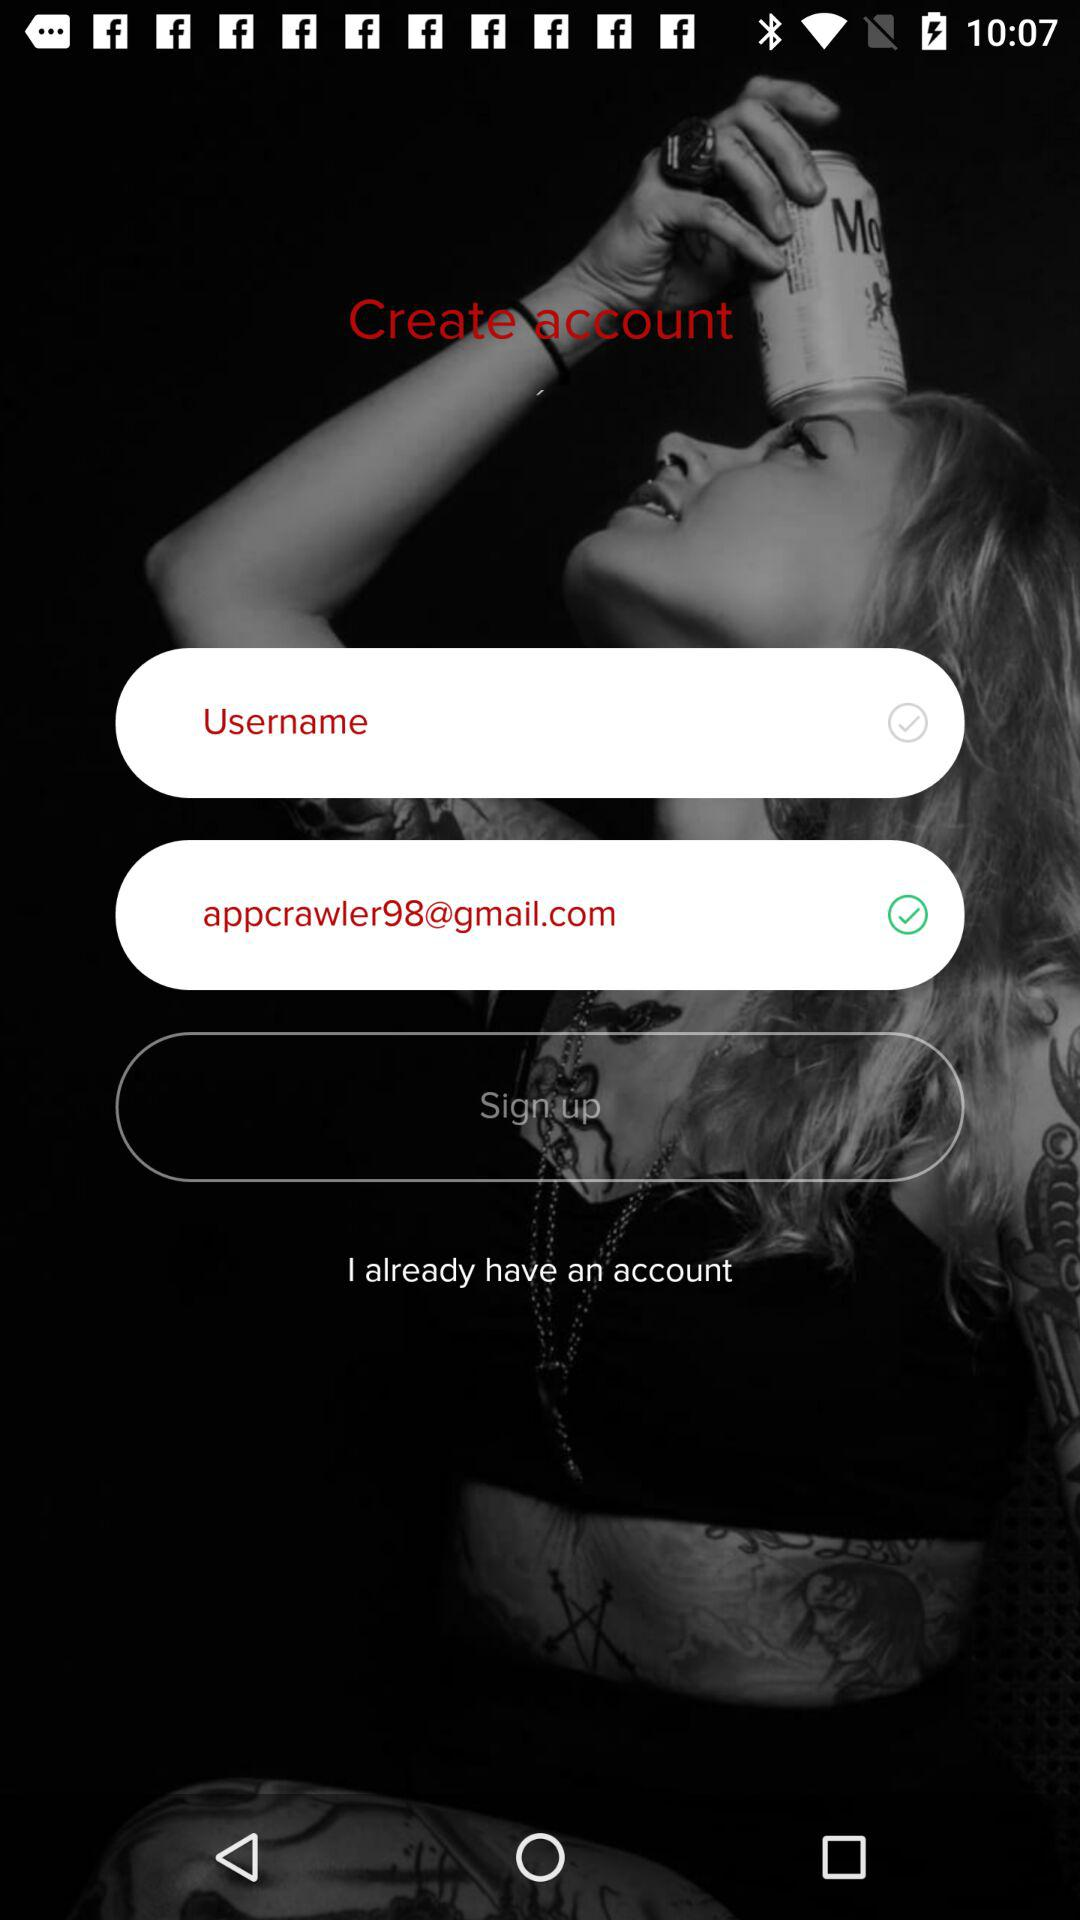How many check marks are on the screen?
Answer the question using a single word or phrase. 2 